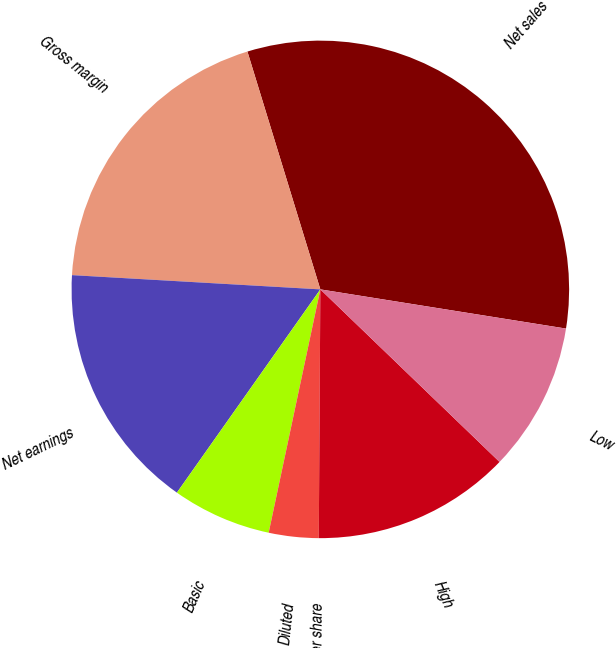<chart> <loc_0><loc_0><loc_500><loc_500><pie_chart><fcel>Net sales<fcel>Gross margin<fcel>Net earnings<fcel>Basic<fcel>Diluted<fcel>Dividends per share<fcel>High<fcel>Low<nl><fcel>32.25%<fcel>19.35%<fcel>16.13%<fcel>6.45%<fcel>3.23%<fcel>0.0%<fcel>12.9%<fcel>9.68%<nl></chart> 